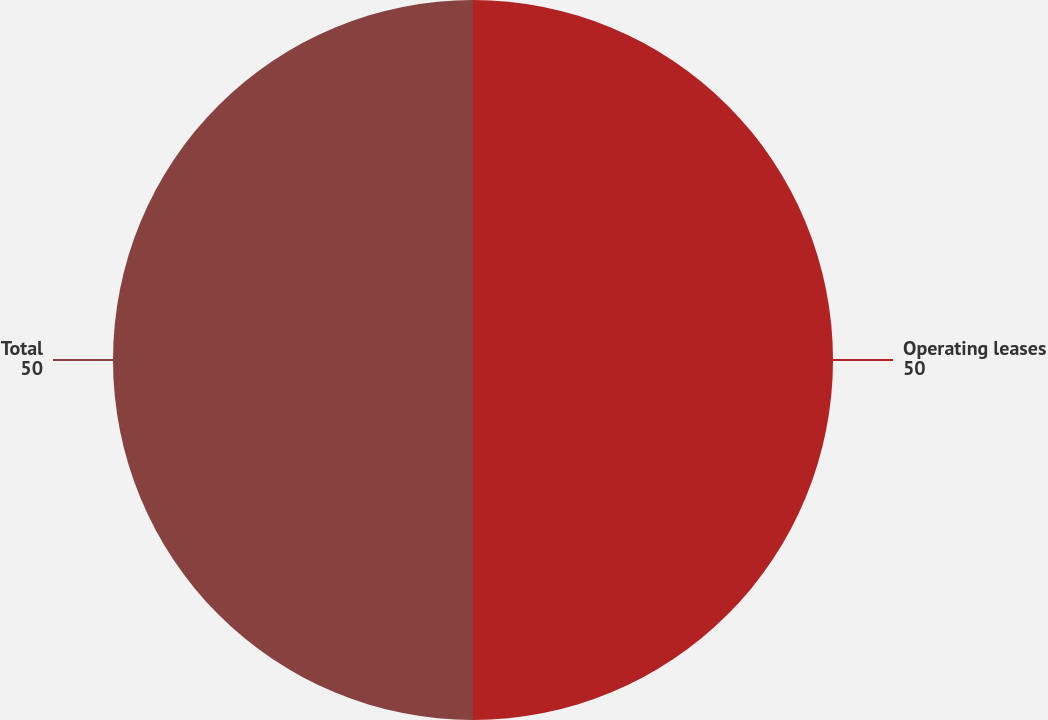Convert chart to OTSL. <chart><loc_0><loc_0><loc_500><loc_500><pie_chart><fcel>Operating leases<fcel>Total<nl><fcel>50.0%<fcel>50.0%<nl></chart> 